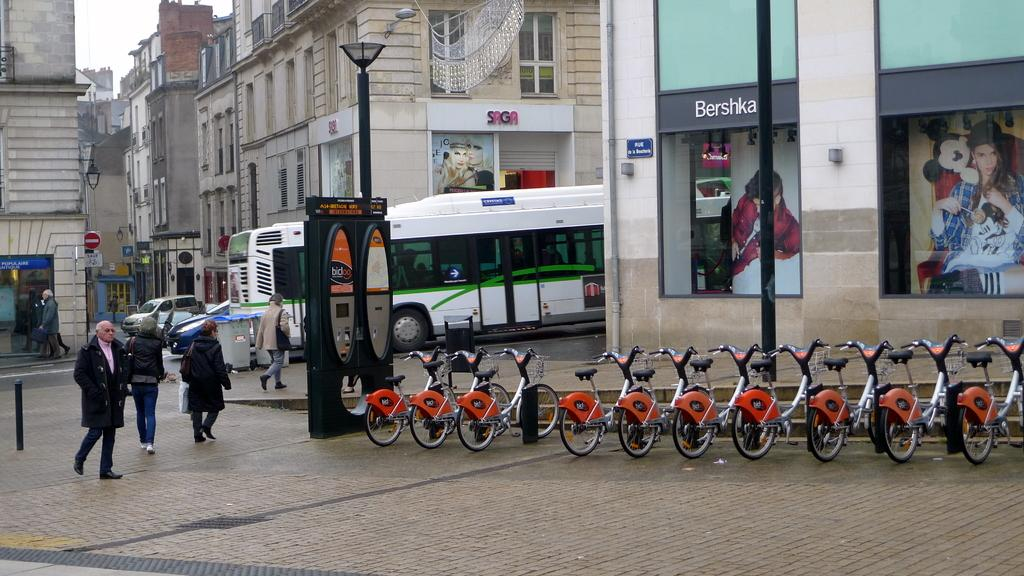<image>
Present a compact description of the photo's key features. row of bikes in front of bershka store as several people walk by 